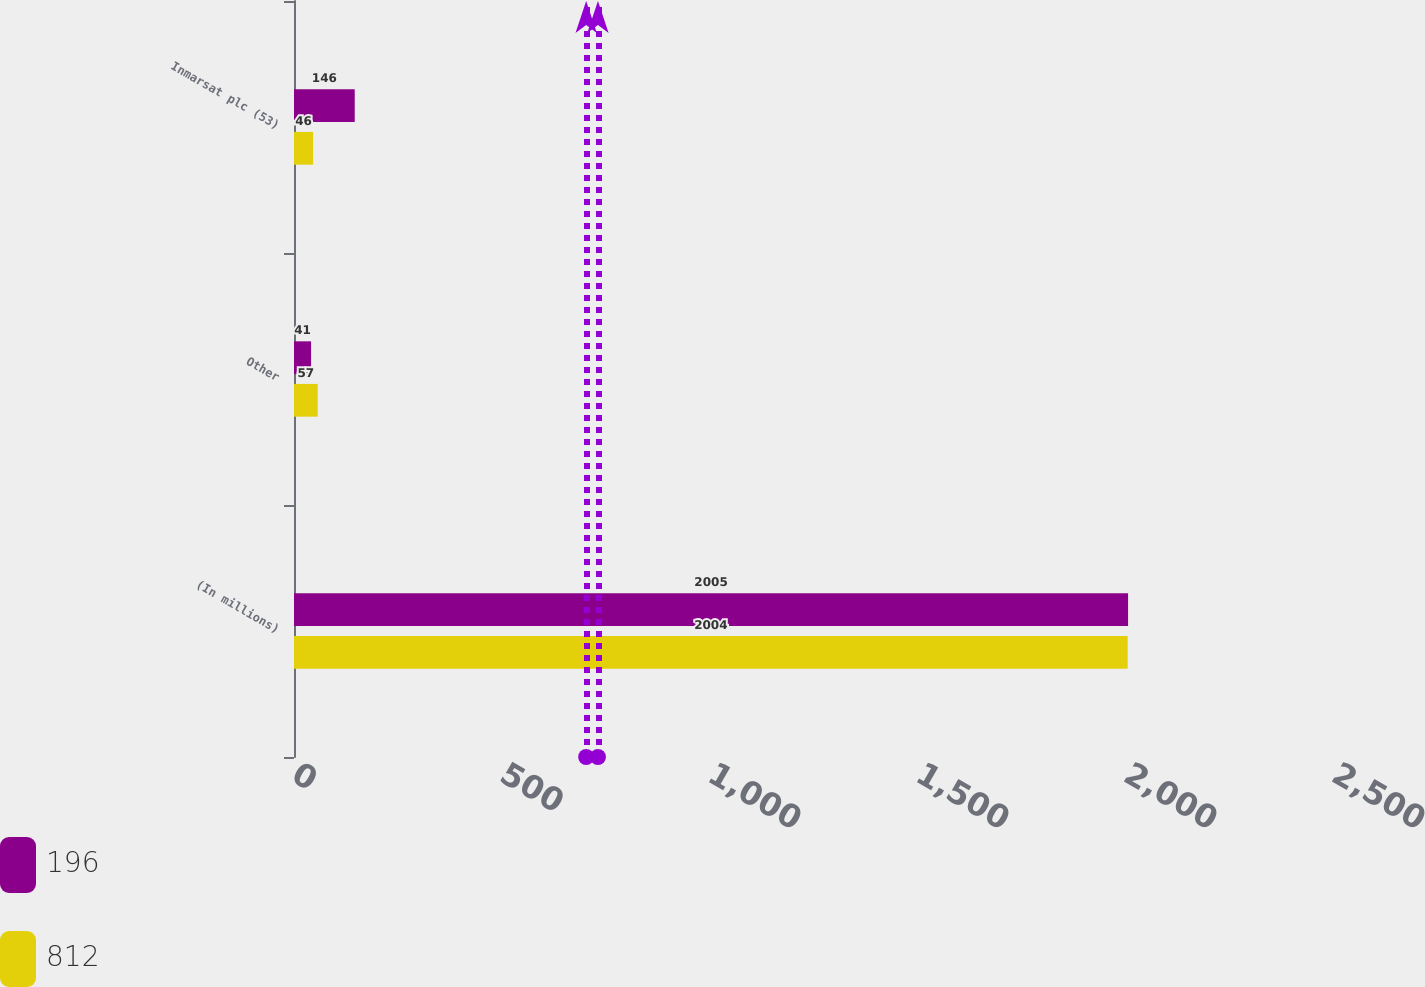Convert chart to OTSL. <chart><loc_0><loc_0><loc_500><loc_500><stacked_bar_chart><ecel><fcel>(In millions)<fcel>Other<fcel>Inmarsat plc (53)<nl><fcel>196<fcel>2005<fcel>41<fcel>146<nl><fcel>812<fcel>2004<fcel>57<fcel>46<nl></chart> 